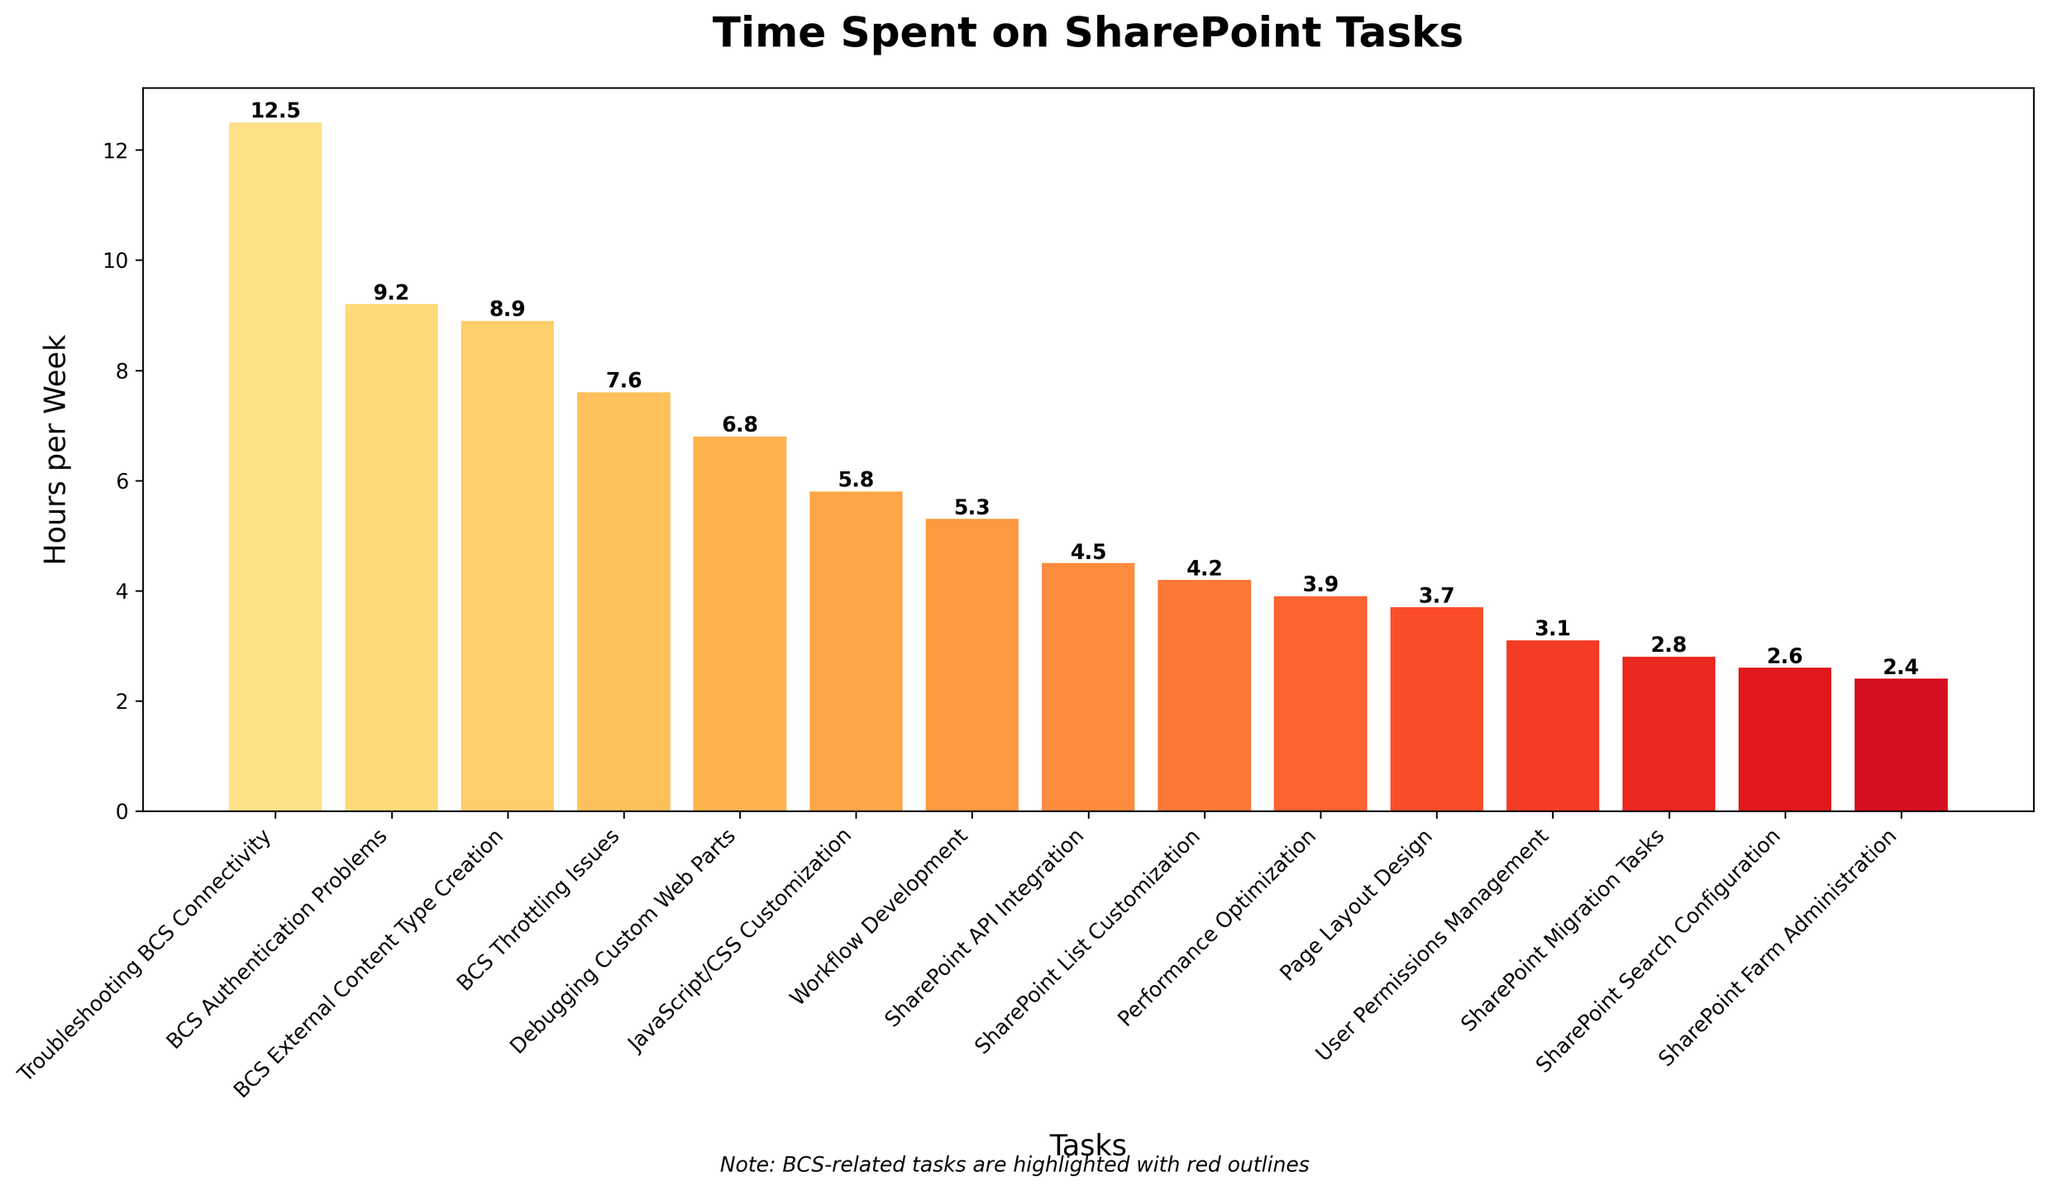Which task took the most time per week? Look for the tallest bar in the chart. The tallest bar represents "Troubleshooting BCS Connectivity" with 12.5 hours per week.
Answer: Troubleshooting BCS Connectivity What is the combined weekly time spent on BCS-related tasks? Identify all the bars for BCS-related tasks: "Troubleshooting BCS Connectivity" (12.5 hours), "BCS External Content Type Creation" (8.9 hours), "BCS Throttling Issues" (7.6 hours), and "BCS Authentication Problems" (9.2 hours). Sum these values: 12.5 + 8.9 + 7.6 + 9.2 = 38.2 hours.
Answer: 38.2 hours Which task spent the least amount of time per week? Locate the shortest bar in the chart. The shortest bar represents "SharePoint Farm Administration" with 2.4 hours per week.
Answer: SharePoint Farm Administration How much more time is spent on Troubleshooting BCS Connectivity compared to SharePoint Search Configuration per week? Identify the hours spent on both tasks: "Troubleshooting BCS Connectivity" (12.5 hours) and "SharePoint Search Configuration" (2.6 hours). Calculate the difference: 12.5 - 2.6 = 9.9 hours.
Answer: 9.9 hours Which non-BCS task spends the most time per week? Exclude BCS-related tasks and compare the heights of the remaining bars. The tallest of these bars represents "Debugging Custom Web Parts" with 6.8 hours per week.
Answer: Debugging Custom Web Parts What is the average time spent on SharePoint development tasks per week? Sum all the hours spent on tasks and divide by the number of tasks. Total hours: 12.5 + 6.8 + 4.2 + 5.3 + 3.7 + 8.9 + 2.6 + 3.1 + 2.4 + 7.6 + 5.8 + 4.5 + 3.9 + 9.2 + 2.8 = 83.3 hours. Number of tasks: 15. Average = 83.3 / 15 = 5.55 hours per week.
Answer: 5.55 hours per week How many tasks take more than 5 hours per week? Count the number of bars taller than the 5-hour mark on the y-axis. There are 8 such tasks: "Troubleshooting BCS Connectivity", "BCS Authentication Problems", "Debugging Custom Web Parts", "BCS External Content Type Creation", "BCS Throttling Issues", "JavaScript/CSS Customization", "Workflow Development", and "SharePoint API Integration".
Answer: 8 tasks Which task related to BCS takes the second most time per week? From the BCS-related tasks, "Troubleshooting BCS Connectivity" is the highest. The next highest bar is "BCS Authentication Problems" with 9.2 hours per week.
Answer: BCS Authentication Problems Compare the combined time spent on Workflow Development and Page Layout Design to that spent on JavaScript/CSS Customization. Which is greater and by how much? Workflow Development (5.3 hours) + Page Layout Design (3.7 hours) = 9 hours. JavaScript/CSS Customization = 5.8 hours. Calculate the difference: 9 - 5.8 = 3.2 hours.
Answer: Workflow Development and Page Layout Design by 3.2 hours 